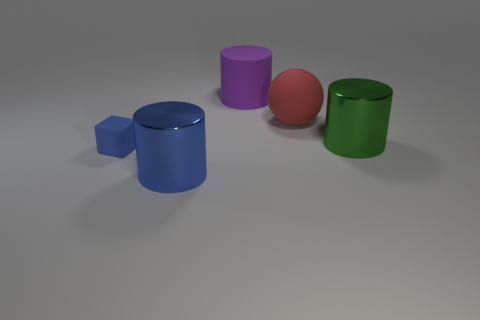Add 2 large blue metal things. How many objects exist? 7 Subtract all spheres. How many objects are left? 4 Subtract all large gray shiny cubes. Subtract all large cylinders. How many objects are left? 2 Add 2 purple cylinders. How many purple cylinders are left? 3 Add 2 big rubber balls. How many big rubber balls exist? 3 Subtract 1 green cylinders. How many objects are left? 4 